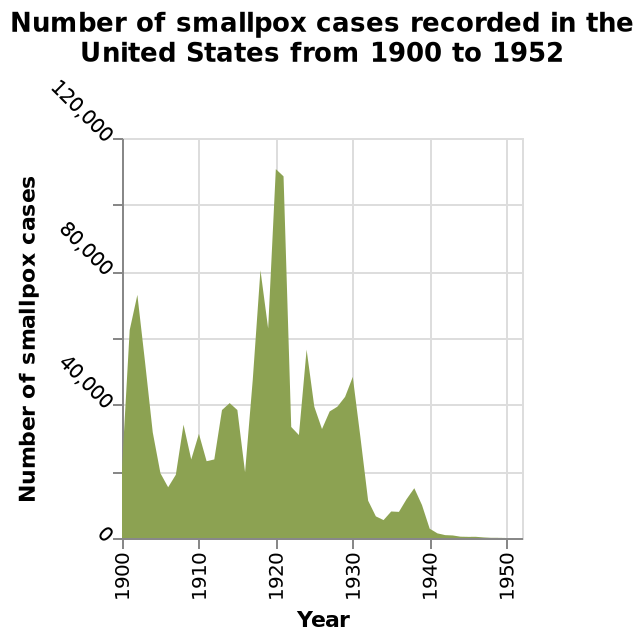<image>
please summary the statistics and relations of the chart The highest number of smallpox cases was recorded in 1920. The lowest number of smallpox cases was between 1940 & 1952. The most number of records are between 20,00 and 40,000. What does the x-axis represent in the area diagram? The x-axis in the area diagram represents the year. What is the range of smallpox cases for the majority of records?  The range of smallpox cases for the majority of records is between 20,000 and 40,000. 